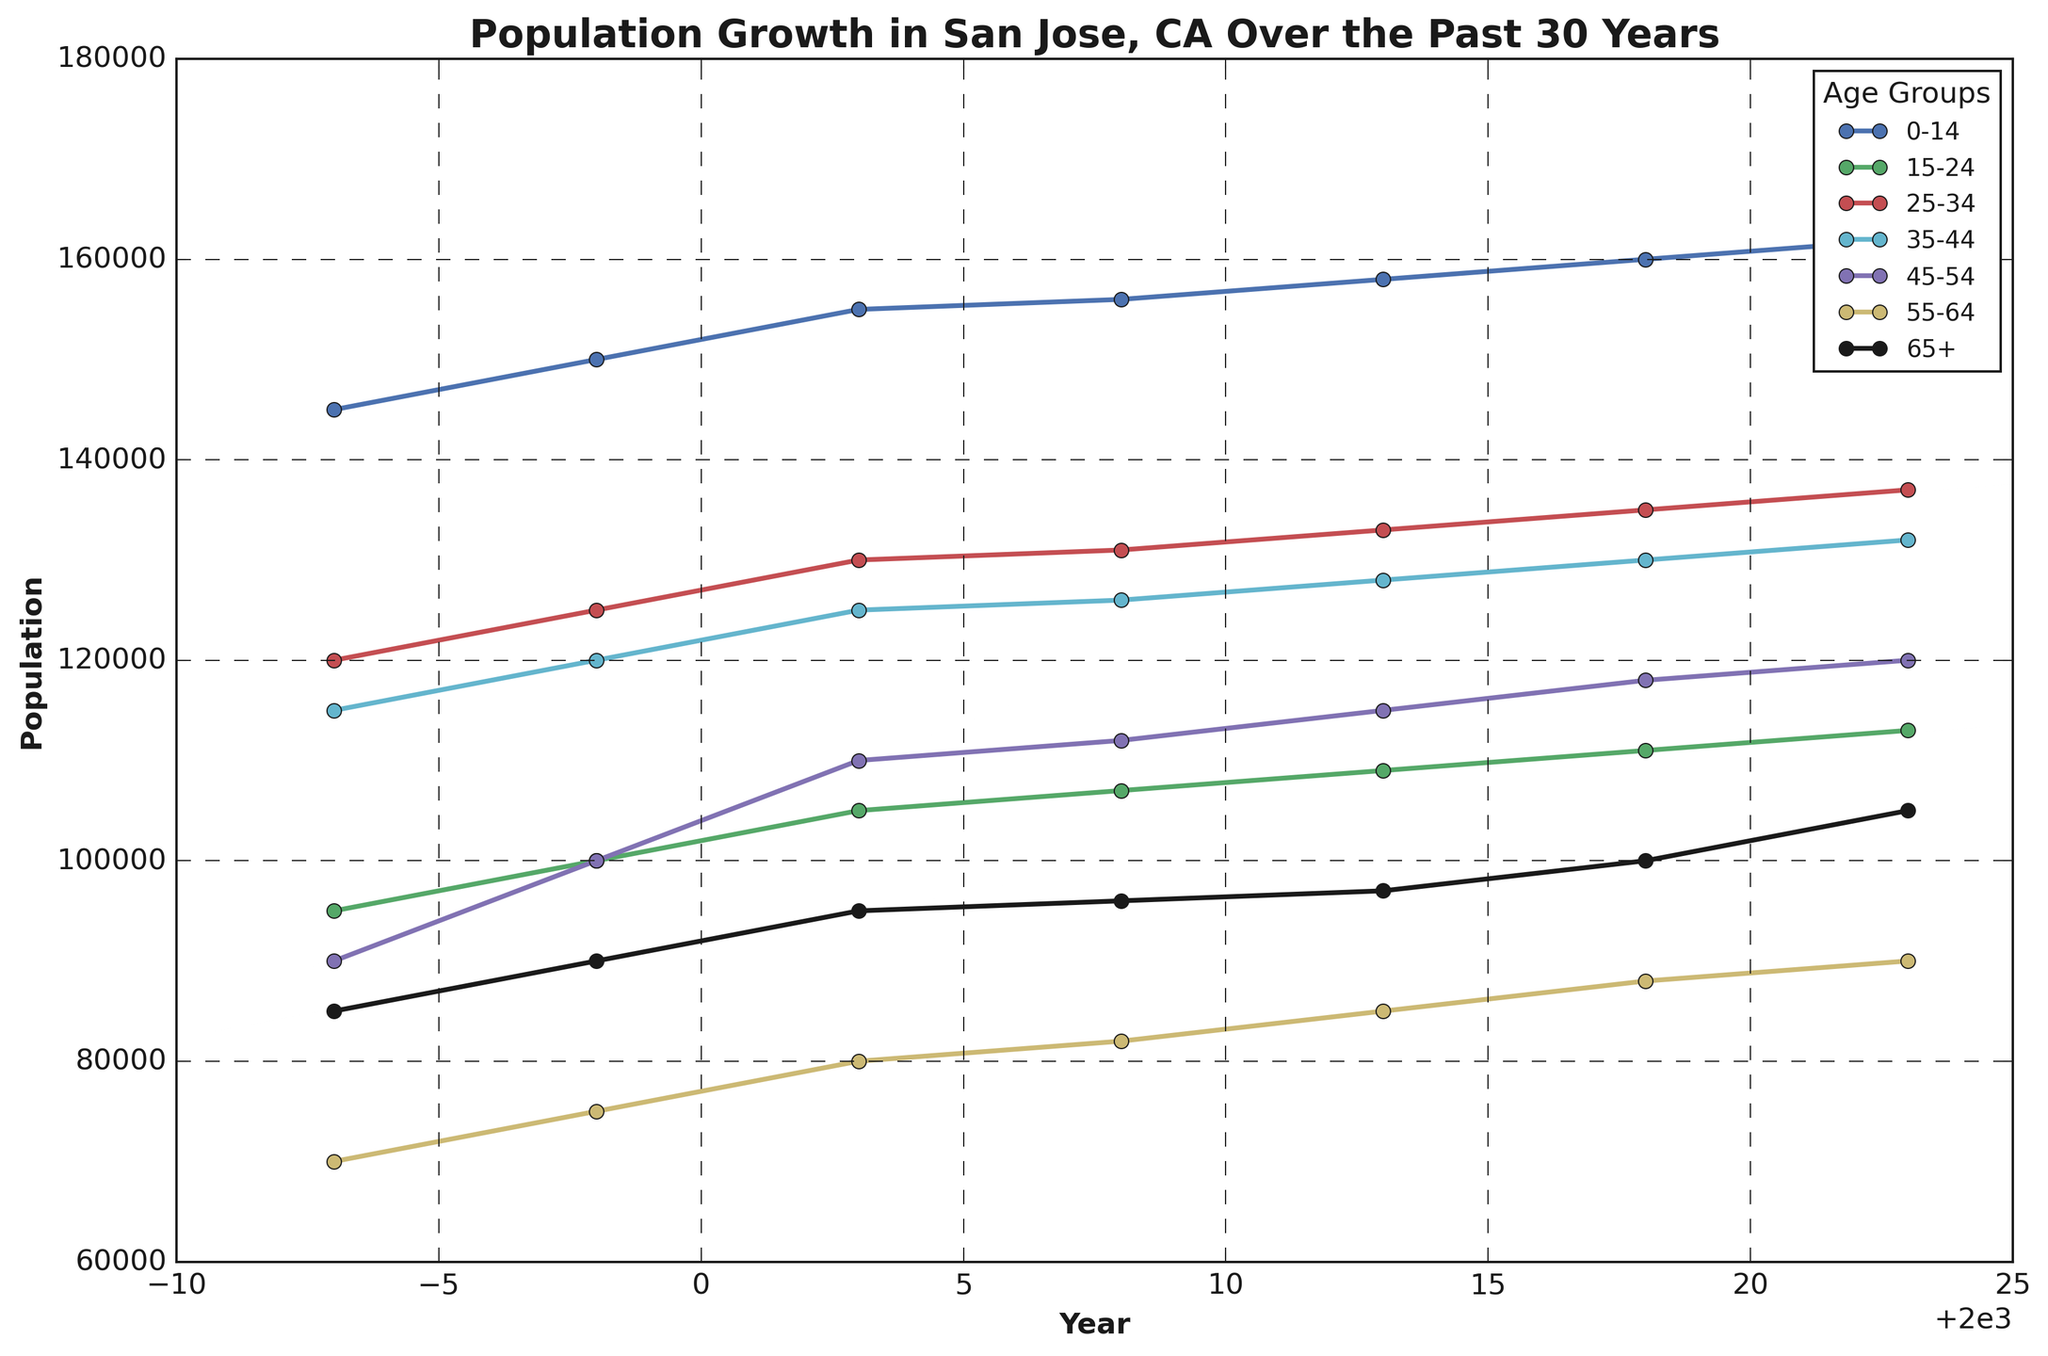What is the total population of San Jose, CA in 2023? Add the population figures for all the age groups in 2023: 162,000 (0-14) + 113,000 (15-24) + 137,000 (25-34) + 132,000 (35-44) + 120,000 (45-54) + 90,000 (55-64) + 105,000 (65+).
Answer: 859,000 Which age group saw the most significant growth in population from 1993 to 2023? Compare the population figures for each age group between 1993 and 2023, and calculate the difference to identify the largest increase: (0-14) +17,000, (15-24) +18,000, (25-34) +17,000, (35-44) +17,000, (45-54) +30,000, (55-64) +20,000, (65+) +20,000.
Answer: 45-54 How did the population of the 55-64 age group change over the 30 years? Observe the population data for the 55-64 age group in different years: 1993 (70,000), 1998 (75,000), 2003 (80,000), 2008 (82,000), 2013 (85,000), 2018 (88,000), 2023 (90,000). Note the overall increasing trend.
Answer: Increased by 20,000 In which year did the 65+ age group first exceed 100,000 in population? Check the population figures for the 65+ age group year by year: 1993 (85,000), 1998 (90,000), 2003 (95,000), 2008 (96,000), 2013 (97,000), 2018 (100,000), 2023 (105,000).
Answer: 2018 Which age group had the smallest population growth from 1993 to 1998? Compare the increase in population for each age group from 1993 to 1998: (0-14) +5,000, (15-24) +5,000, (25-34) +5,000, (35-44) +5,000, (45-54) +10,000, (55-64) +5,000, (65+) +5,000. The smallest increase occurs equally across several groups.
Answer: Multiple groups with +5,000 Which age group had a steady increase in population every 5 years? Observe the trendlines for each age group. The lines should show continuous increases without any flat or decrement periods. The 0-14, 15-24, 25-34, 35-44, and 65+ groups show consistent growth. Compare steepness and consistency.
Answer: Several groups including 0-14, 15-24, 25-34, 35-44, 65+ Which year showed the smallest total population across all age groups? Calculate the total population for each year. The year with the smallest total population is the year 1993 with 810,000. 1993 (810,000), 1998 (860,000), 2003 (900,000), 2008 (910,000), 2013 (920,000), 2018 (930,000), and 2023 (970,000).
Answer: 1993 What was the average population for the age group 25-34 across the entire period? Add the population figures for 25-34 age group in each year and divide by the number of years: (120,000 + 125,000 + 130,000 + 131,000 + 133,000 + 135,000 + 137,000) / 7.
Answer: 130,143 